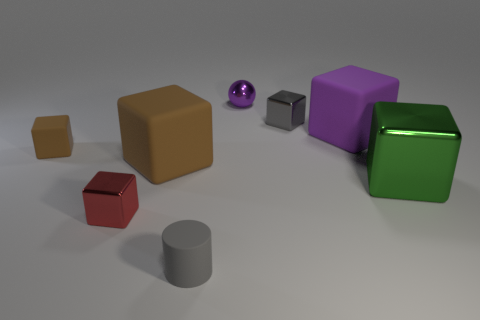Subtract 1 blocks. How many blocks are left? 5 Subtract all green blocks. How many blocks are left? 5 Subtract all tiny brown rubber blocks. How many blocks are left? 5 Subtract all yellow cubes. Subtract all red spheres. How many cubes are left? 6 Add 1 large brown things. How many objects exist? 9 Subtract all balls. How many objects are left? 7 Subtract 0 red spheres. How many objects are left? 8 Subtract all large yellow metal things. Subtract all big purple rubber cubes. How many objects are left? 7 Add 5 shiny balls. How many shiny balls are left? 6 Add 8 tiny cyan rubber things. How many tiny cyan rubber things exist? 8 